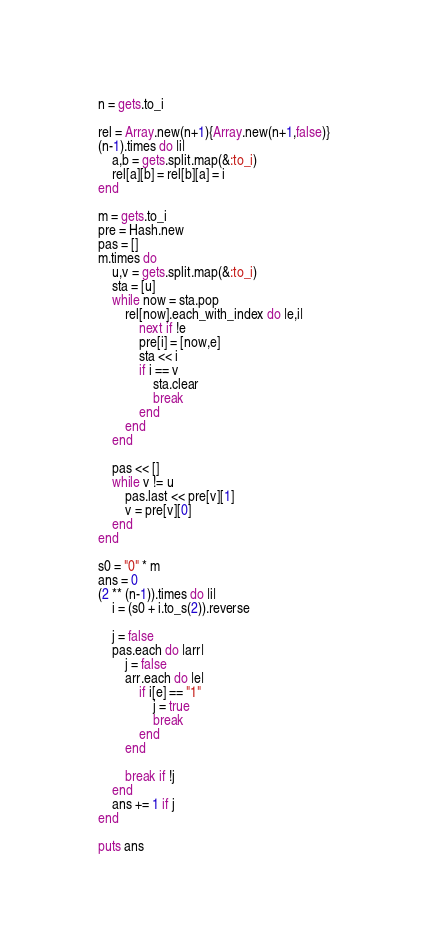Convert code to text. <code><loc_0><loc_0><loc_500><loc_500><_Ruby_>n = gets.to_i

rel = Array.new(n+1){Array.new(n+1,false)}
(n-1).times do |i|
    a,b = gets.split.map(&:to_i)
    rel[a][b] = rel[b][a] = i
end

m = gets.to_i
pre = Hash.new
pas = []
m.times do 
    u,v = gets.split.map(&:to_i)
    sta = [u]
    while now = sta.pop
        rel[now].each_with_index do |e,i|
            next if !e
            pre[i] = [now,e]
            sta << i
            if i == v
                sta.clear
                break
            end
        end
    end

    pas << []
    while v != u
        pas.last << pre[v][1]
        v = pre[v][0]
    end
end

s0 = "0" * m
ans = 0
(2 ** (n-1)).times do |i|
    i = (s0 + i.to_s(2)).reverse

    j = false
    pas.each do |arr|
        j = false
        arr.each do |e|
            if i[e] == "1"
                j = true
                break
            end
        end

        break if !j
    end
    ans += 1 if j
end

puts ans</code> 